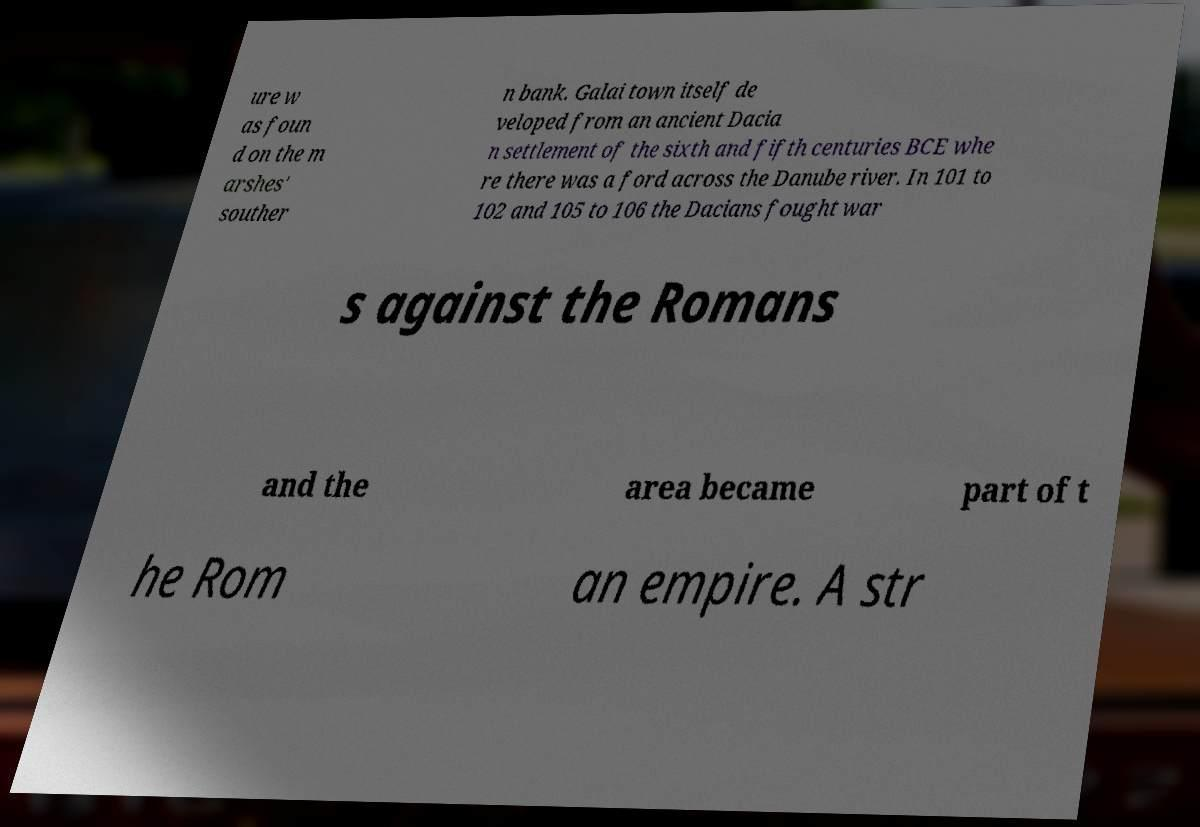I need the written content from this picture converted into text. Can you do that? ure w as foun d on the m arshes' souther n bank. Galai town itself de veloped from an ancient Dacia n settlement of the sixth and fifth centuries BCE whe re there was a ford across the Danube river. In 101 to 102 and 105 to 106 the Dacians fought war s against the Romans and the area became part of t he Rom an empire. A str 